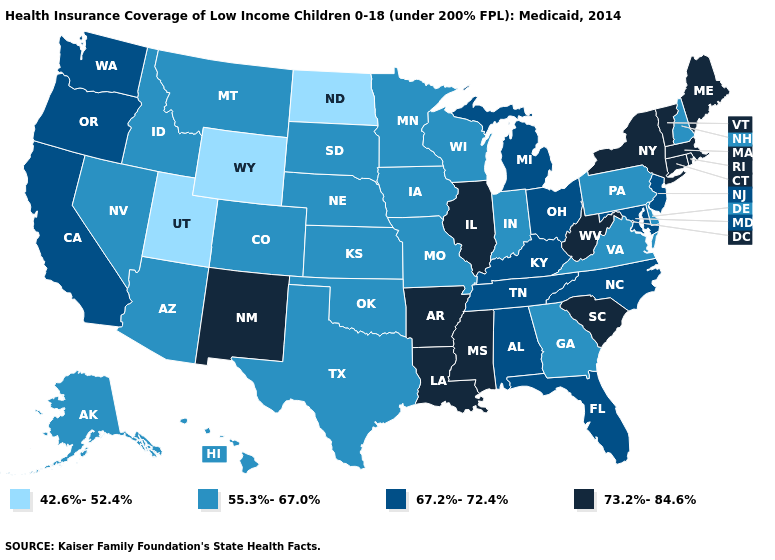What is the value of Connecticut?
Write a very short answer. 73.2%-84.6%. Which states have the highest value in the USA?
Answer briefly. Arkansas, Connecticut, Illinois, Louisiana, Maine, Massachusetts, Mississippi, New Mexico, New York, Rhode Island, South Carolina, Vermont, West Virginia. What is the value of New Jersey?
Write a very short answer. 67.2%-72.4%. Which states hav the highest value in the MidWest?
Short answer required. Illinois. Which states have the highest value in the USA?
Give a very brief answer. Arkansas, Connecticut, Illinois, Louisiana, Maine, Massachusetts, Mississippi, New Mexico, New York, Rhode Island, South Carolina, Vermont, West Virginia. Among the states that border Indiana , which have the lowest value?
Quick response, please. Kentucky, Michigan, Ohio. Among the states that border Florida , which have the highest value?
Be succinct. Alabama. What is the value of Idaho?
Keep it brief. 55.3%-67.0%. What is the value of Oklahoma?
Keep it brief. 55.3%-67.0%. Name the states that have a value in the range 73.2%-84.6%?
Be succinct. Arkansas, Connecticut, Illinois, Louisiana, Maine, Massachusetts, Mississippi, New Mexico, New York, Rhode Island, South Carolina, Vermont, West Virginia. What is the value of Maryland?
Quick response, please. 67.2%-72.4%. Among the states that border Idaho , does Wyoming have the highest value?
Write a very short answer. No. Does Illinois have the highest value in the MidWest?
Concise answer only. Yes. Does Nebraska have a lower value than Ohio?
Keep it brief. Yes. Among the states that border South Carolina , does Georgia have the highest value?
Be succinct. No. 